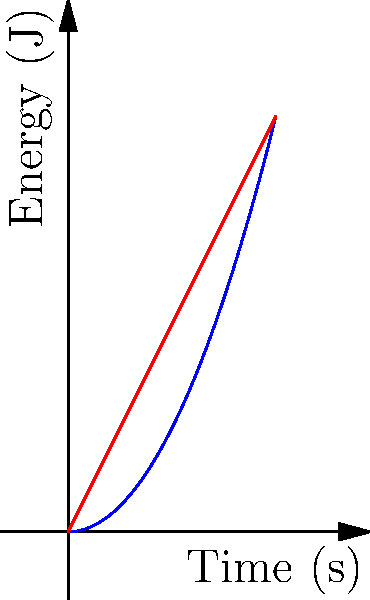As a basketball enthusiast familiar with John Stockton's legendary passing skills, consider the energy transfer in a chest pass versus an overhead pass. Based on the motion graphs shown, which type of pass would likely result in a higher velocity of the ball at release, assuming equal effort is applied? To answer this question, we need to analyze the energy transfer graphs for both types of passes:

1. The blue curve represents the chest pass, while the red line represents the overhead pass.

2. The vertical axis shows energy (J), and the horizontal axis shows time (s).

3. For the chest pass (blue curve):
   - The energy increases quadratically over time (parabolic shape).
   - This suggests a gradual increase in energy transfer, starting slow and accelerating.

4. For the overhead pass (red line):
   - The energy increases linearly over time.
   - This indicates a constant rate of energy transfer throughout the motion.

5. At the end of the motion (around 4 seconds), the overhead pass graph shows a higher energy value than the chest pass.

6. Since kinetic energy is directly related to velocity (KE = 1/2 * m * v^2), a higher energy at release implies a higher velocity.

7. Therefore, the overhead pass would likely result in a higher velocity of the ball at release, assuming equal effort is applied.

This analysis aligns with the mechanics of passing in basketball. An overhead pass typically allows for a longer acceleration path and utilizes more of the body's kinetic chain, potentially resulting in a higher release velocity compared to a chest pass.
Answer: Overhead pass 